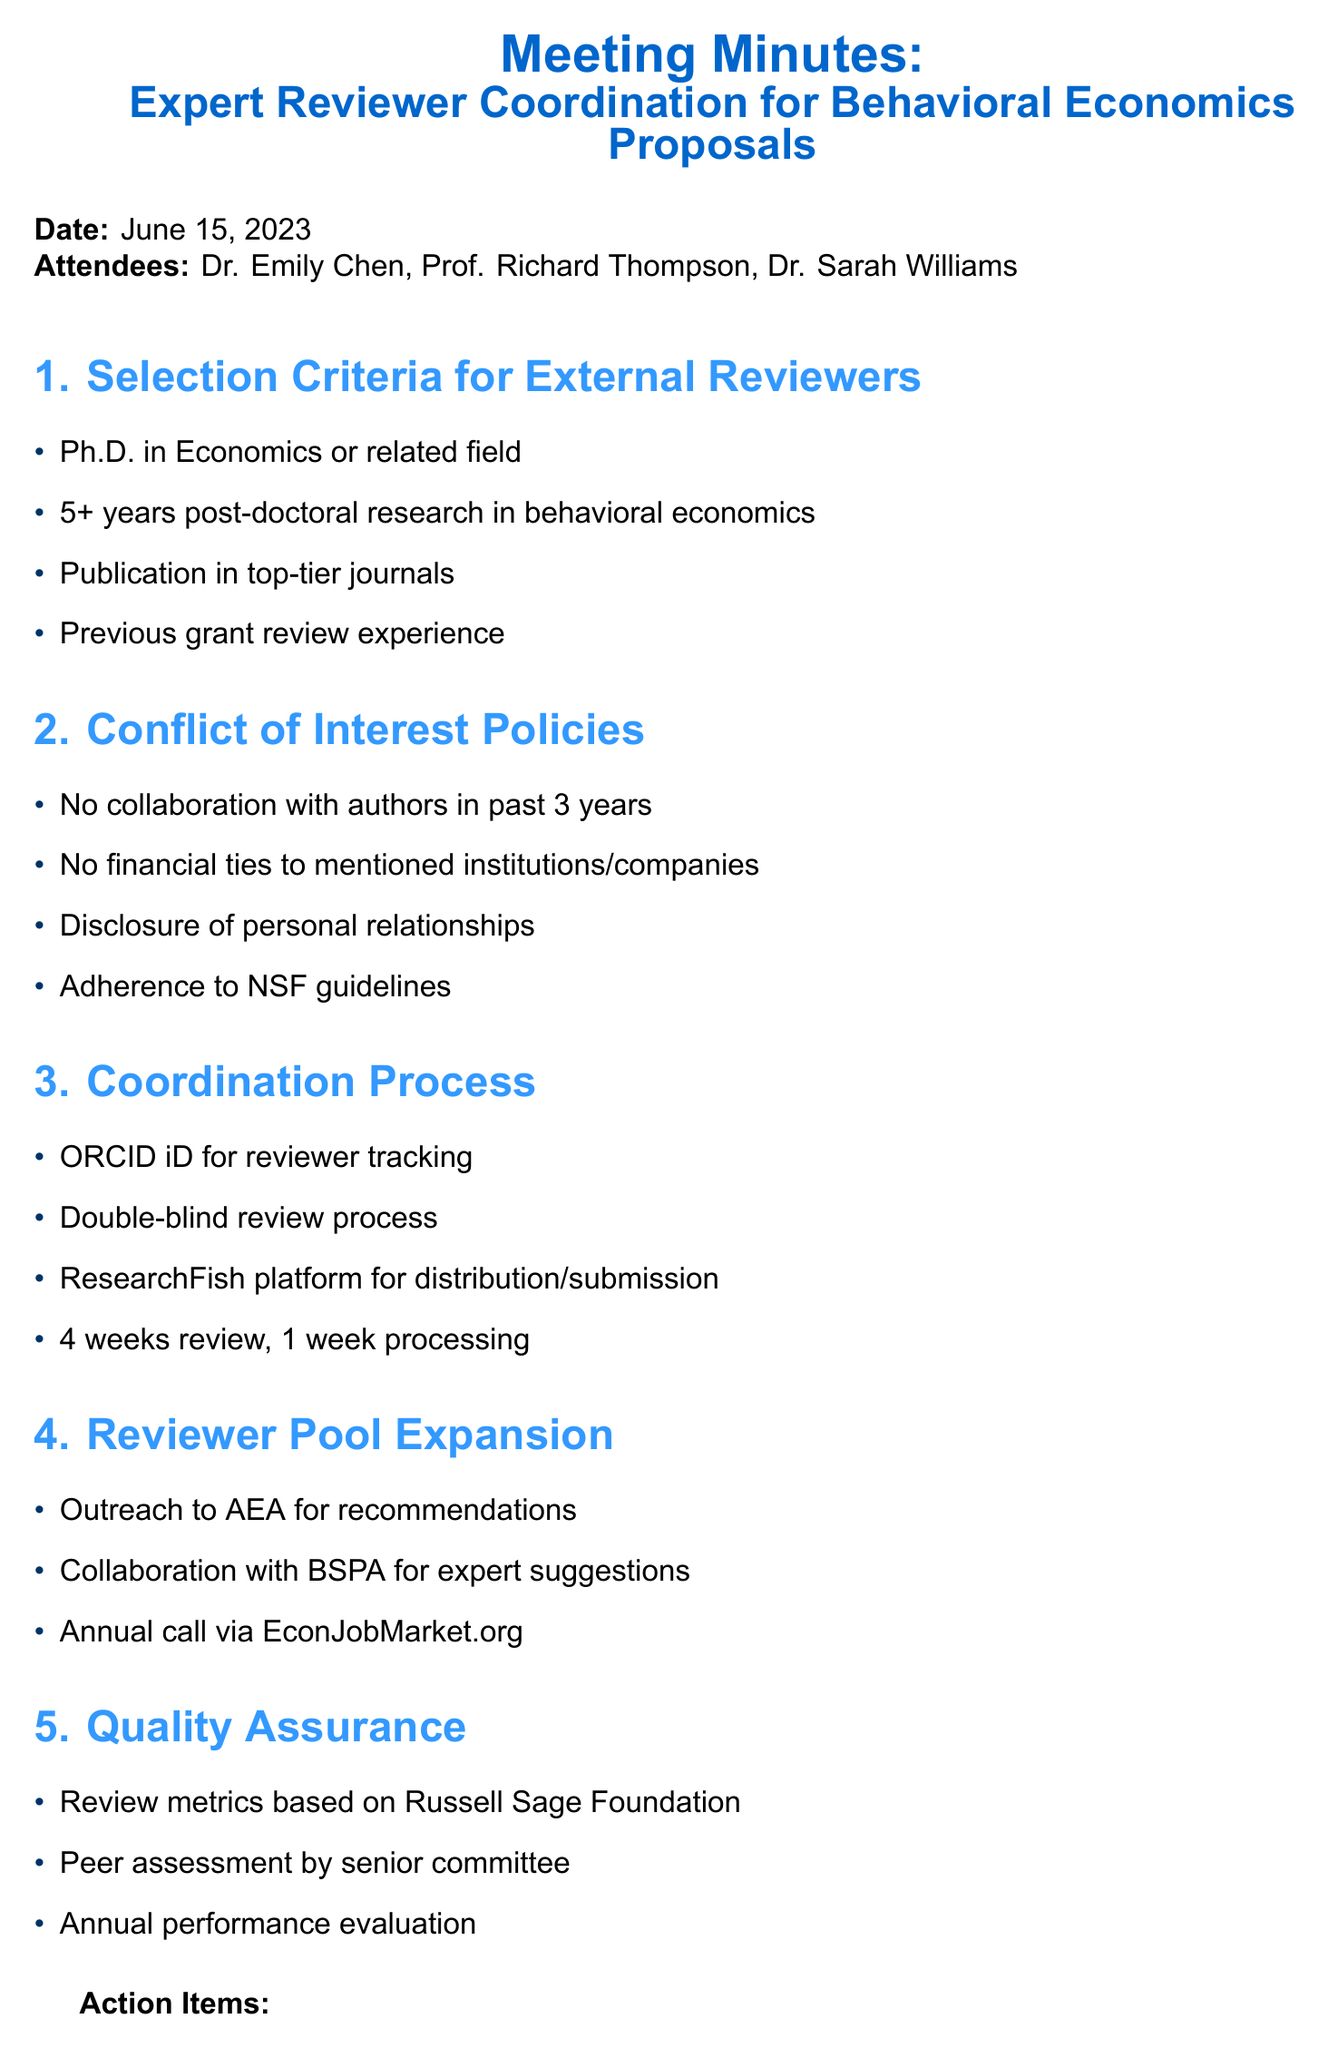what is the date of the meeting? The date of the meeting is explicitly stated in the document.
Answer: June 15, 2023 who is the Head of the Economics Department? The document lists attendees and their titles, providing the name of the Head of the Economics Department.
Answer: Prof. Richard Thompson how many years of post-doctoral research experience is required for external reviewers? The selection criteria specify the minimum required post-doctoral research experience in behavioral economics.
Answer: 5 years what platform will be used for proposal distribution and review submission? The coordination process section details the specific platform intended for distribution and submission.
Answer: ResearchFish what organization will be contacted for reviewer recommendations? The reviewer pool expansion section mentions outreach to a specific organization for recommendations.
Answer: American Economic Association (AEA) what is the timeline for the review completion? The coordination process outlines the expected timeline for review and administrative processing.
Answer: 4 weeks for review completion, 1 week for administrative processing what are the consequences for reviewers regarding financial ties? The conflict of interest policies clearly outline the expectations related to financial ties.
Answer: No financial ties to institutions or companies mentioned in proposals what action item involves updating conflict of interest forms? The action items list includes tasks to be completed, specifically regarding conflict of interest policies.
Answer: Draft revised conflict of interest disclosure form 